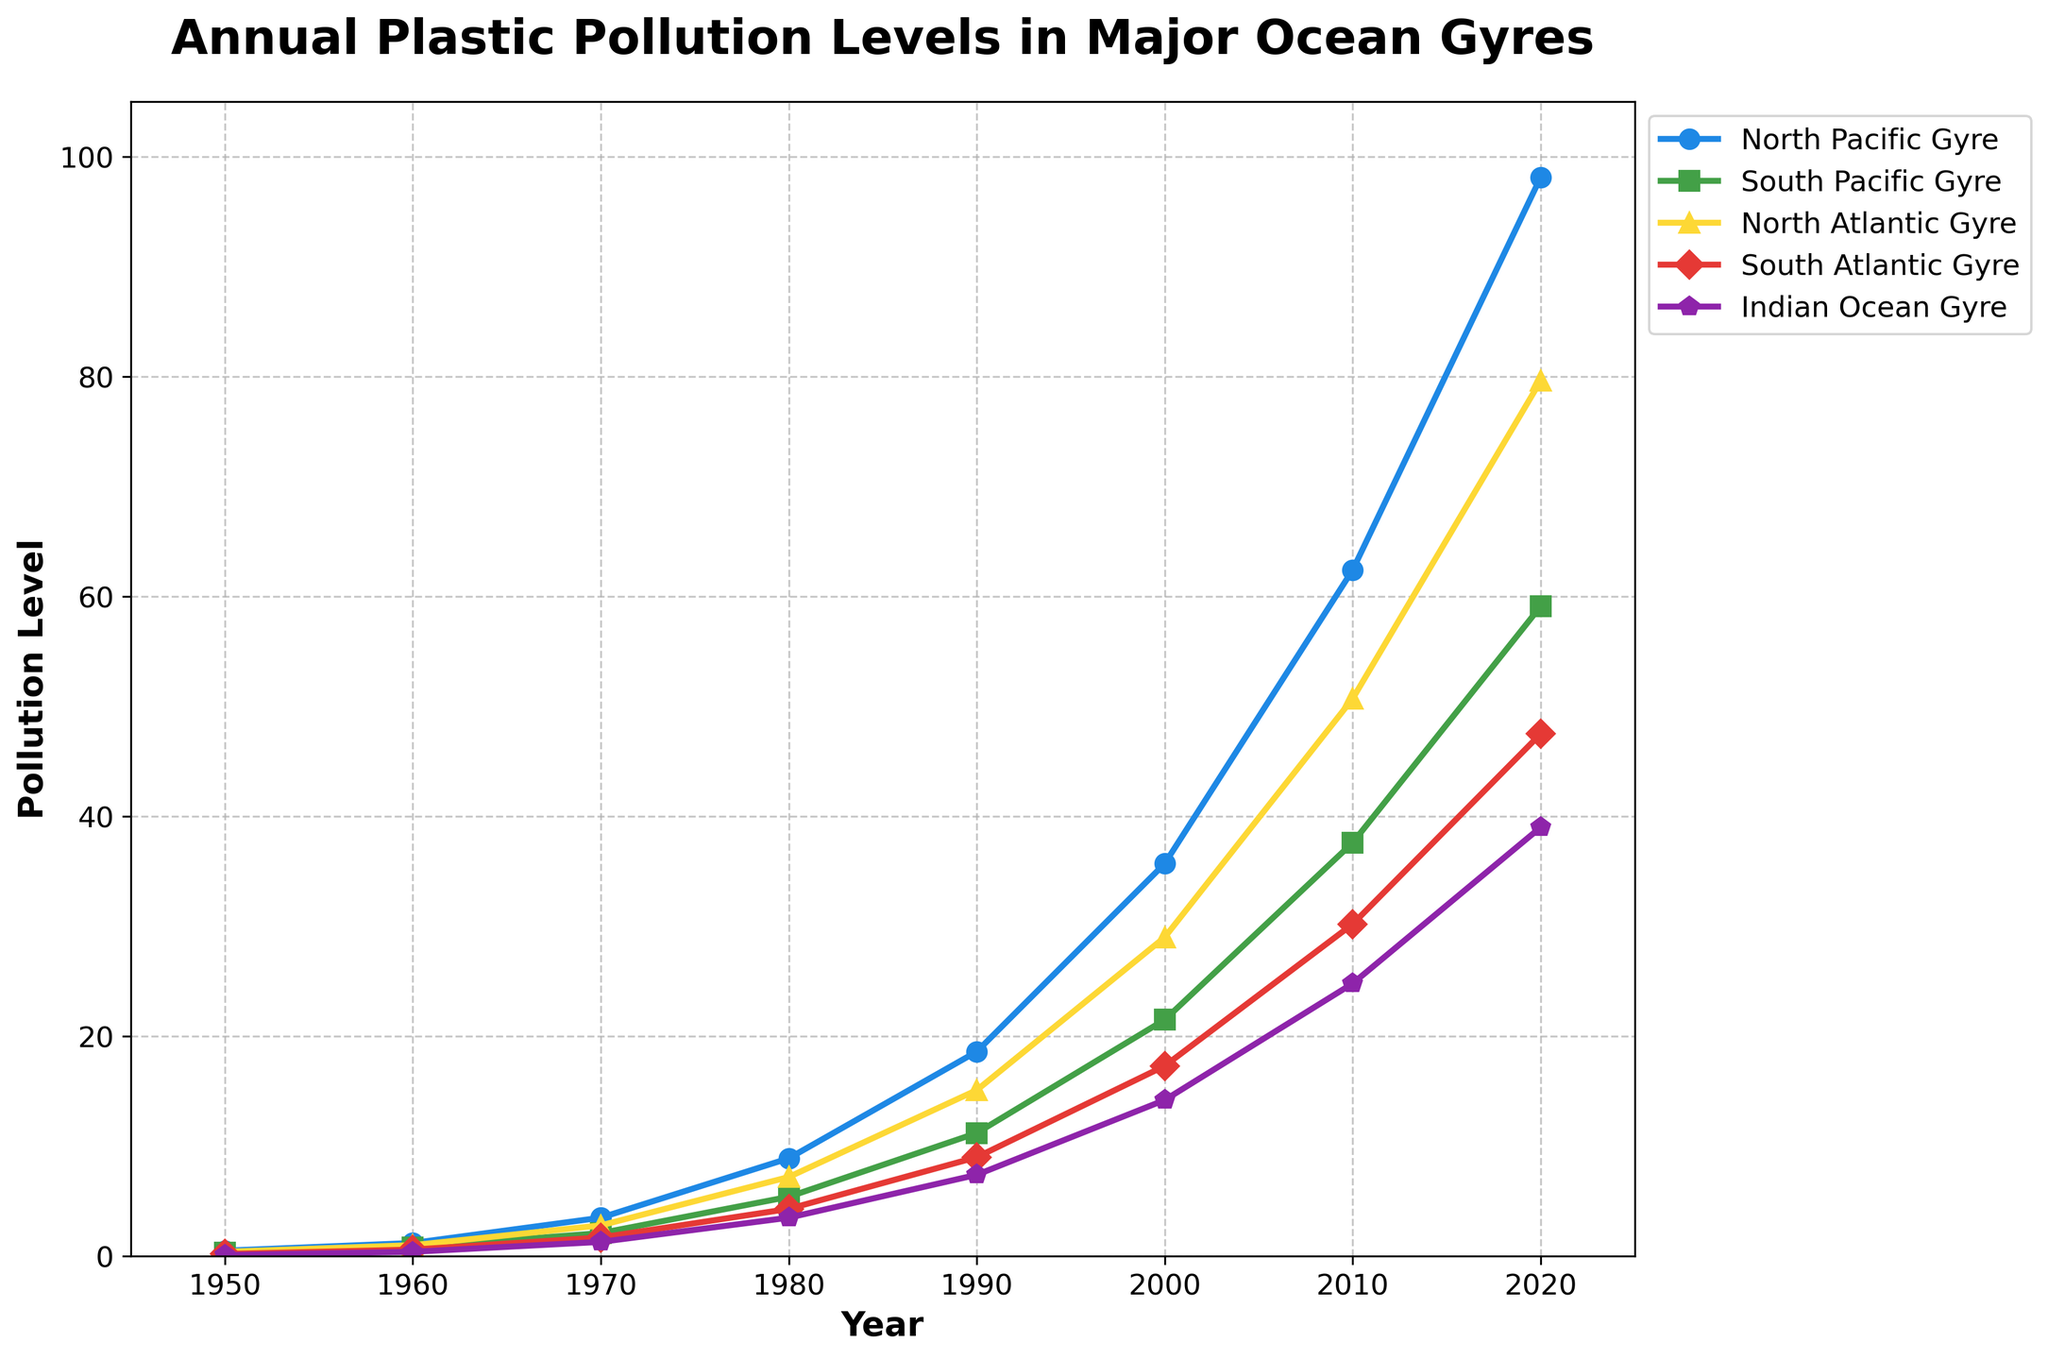What was the pollution level in the North Pacific Gyre in 1970, and how does it compare to the pollution level in the South Atlantic Gyre in the same year? In 1970, the pollution level in the North Pacific Gyre was 3.5, and in the South Atlantic Gyre, it was 1.7. Comparing these values, we see that the North Pacific Gyre had a higher pollution level.
Answer: North Pacific Gyre had more pollution Which gyre had the highest pollution level in 2020? In 2020, the pollution levels for the gyres were: North Pacific Gyre (98.1), South Pacific Gyre (59.1), North Atlantic Gyre (79.6), South Atlantic Gyre (47.5), and Indian Ocean Gyre (39.0). The North Pacific Gyre had the highest pollution level at 98.1.
Answer: North Pacific Gyre Between which years did the North Atlantic Gyre see the greatest increase in pollution levels? The increases from decade to decade for the North Atlantic Gyre were: 0.6 (1950-1960), 1.8 (1960-1970), 4.4 (1970-1980), 7.9 (1980-1990), 13.9 (1990-2000), 21.7 (2000-2010), and 28.9 (2010-2020). The greatest increase was between 2010 and 2020.
Answer: 2010-2020 By how much did the pollution level in the Indian Ocean Gyre increase from 1950 to 2020? The pollution level in the Indian Ocean Gyre was 0.1 in 1950 and 39.0 in 2020. The increase is 39.0 - 0.1 = 38.9.
Answer: 38.9 What was the average pollution level across all gyres in 1980? The pollution levels in 1980 were 8.9 (North Pacific Gyre), 5.4 (South Pacific Gyre), 7.2 (North Atlantic Gyre), 4.3 (South Atlantic Gyre), and 3.5 (Indian Ocean Gyre). The average is (8.9 + 5.4 + 7.2 + 4.3 + 3.5) / 5 = 5.86.
Answer: 5.86 Between 1950 and 2020, how many times did the pollution level in the North Atlantic Gyre exceed that in the South Atlantic Gyre? Comparing the values for each decade: 1960, 1970, 1980, 1990, 2000, 2010, and 2020, the pollution level in the North Atlantic Gyre always exceeded that in the South Atlantic Gyre. That's 7 times.
Answer: 7 times In which decade did the South Atlantic Gyre experience the smallest growth in pollution levels, and what was that growth? The growth between each decade for the South Atlantic Gyre was: 0.4 (1950-1960), 1.1 (1960-1970), 2.6 (1970-1980), 4.7 (1980-1990), 8.3 (1990-2000), 12.9 (2000-2010), and 17.3 (2010-2020). The smallest growth was between 1950 and 1960, with an increase of 0.4.
Answer: 1950-1960, 0.4 